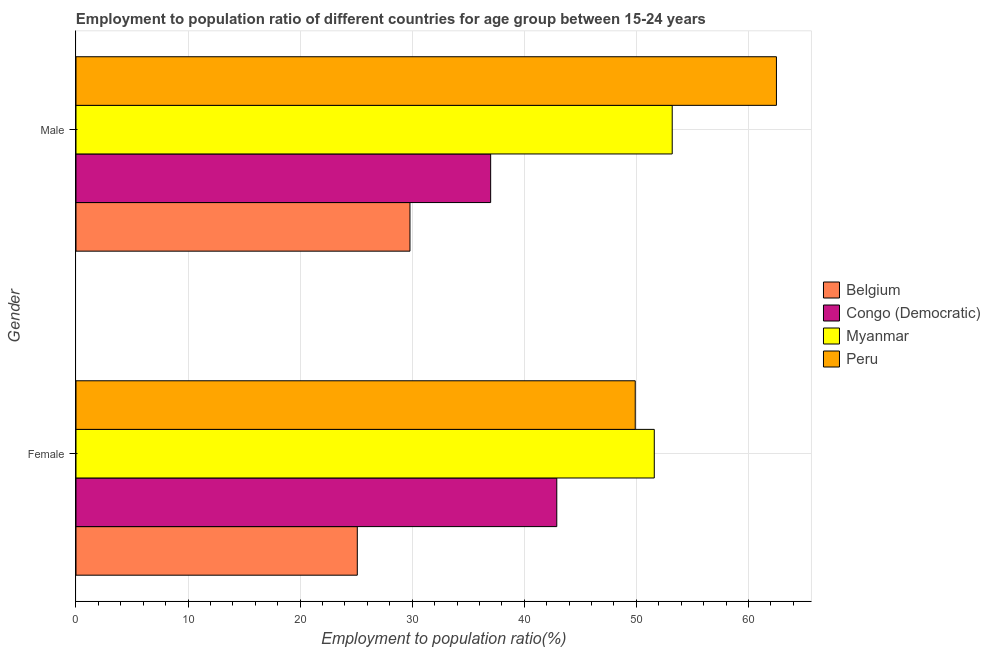How many groups of bars are there?
Provide a succinct answer. 2. How many bars are there on the 2nd tick from the top?
Offer a terse response. 4. What is the label of the 2nd group of bars from the top?
Keep it short and to the point. Female. What is the employment to population ratio(female) in Myanmar?
Keep it short and to the point. 51.6. Across all countries, what is the maximum employment to population ratio(male)?
Provide a short and direct response. 62.5. Across all countries, what is the minimum employment to population ratio(female)?
Provide a short and direct response. 25.1. In which country was the employment to population ratio(male) minimum?
Give a very brief answer. Belgium. What is the total employment to population ratio(female) in the graph?
Your answer should be compact. 169.5. What is the difference between the employment to population ratio(male) in Belgium and the employment to population ratio(female) in Peru?
Offer a very short reply. -20.1. What is the average employment to population ratio(female) per country?
Your answer should be compact. 42.38. What is the difference between the employment to population ratio(male) and employment to population ratio(female) in Myanmar?
Make the answer very short. 1.6. In how many countries, is the employment to population ratio(male) greater than 48 %?
Your response must be concise. 2. What is the ratio of the employment to population ratio(male) in Congo (Democratic) to that in Belgium?
Ensure brevity in your answer.  1.24. In how many countries, is the employment to population ratio(male) greater than the average employment to population ratio(male) taken over all countries?
Give a very brief answer. 2. What does the 2nd bar from the top in Male represents?
Make the answer very short. Myanmar. What does the 3rd bar from the bottom in Female represents?
Offer a terse response. Myanmar. Are the values on the major ticks of X-axis written in scientific E-notation?
Your response must be concise. No. Where does the legend appear in the graph?
Keep it short and to the point. Center right. What is the title of the graph?
Offer a terse response. Employment to population ratio of different countries for age group between 15-24 years. What is the label or title of the X-axis?
Your answer should be compact. Employment to population ratio(%). What is the label or title of the Y-axis?
Provide a succinct answer. Gender. What is the Employment to population ratio(%) in Belgium in Female?
Ensure brevity in your answer.  25.1. What is the Employment to population ratio(%) of Congo (Democratic) in Female?
Offer a terse response. 42.9. What is the Employment to population ratio(%) in Myanmar in Female?
Offer a very short reply. 51.6. What is the Employment to population ratio(%) in Peru in Female?
Give a very brief answer. 49.9. What is the Employment to population ratio(%) of Belgium in Male?
Make the answer very short. 29.8. What is the Employment to population ratio(%) of Congo (Democratic) in Male?
Your answer should be very brief. 37. What is the Employment to population ratio(%) of Myanmar in Male?
Your response must be concise. 53.2. What is the Employment to population ratio(%) of Peru in Male?
Make the answer very short. 62.5. Across all Gender, what is the maximum Employment to population ratio(%) in Belgium?
Ensure brevity in your answer.  29.8. Across all Gender, what is the maximum Employment to population ratio(%) of Congo (Democratic)?
Your response must be concise. 42.9. Across all Gender, what is the maximum Employment to population ratio(%) of Myanmar?
Provide a short and direct response. 53.2. Across all Gender, what is the maximum Employment to population ratio(%) in Peru?
Your answer should be compact. 62.5. Across all Gender, what is the minimum Employment to population ratio(%) of Belgium?
Make the answer very short. 25.1. Across all Gender, what is the minimum Employment to population ratio(%) of Congo (Democratic)?
Keep it short and to the point. 37. Across all Gender, what is the minimum Employment to population ratio(%) of Myanmar?
Ensure brevity in your answer.  51.6. Across all Gender, what is the minimum Employment to population ratio(%) in Peru?
Provide a succinct answer. 49.9. What is the total Employment to population ratio(%) in Belgium in the graph?
Your answer should be compact. 54.9. What is the total Employment to population ratio(%) of Congo (Democratic) in the graph?
Provide a succinct answer. 79.9. What is the total Employment to population ratio(%) in Myanmar in the graph?
Make the answer very short. 104.8. What is the total Employment to population ratio(%) of Peru in the graph?
Give a very brief answer. 112.4. What is the difference between the Employment to population ratio(%) of Belgium in Female and the Employment to population ratio(%) of Myanmar in Male?
Offer a very short reply. -28.1. What is the difference between the Employment to population ratio(%) in Belgium in Female and the Employment to population ratio(%) in Peru in Male?
Your answer should be very brief. -37.4. What is the difference between the Employment to population ratio(%) of Congo (Democratic) in Female and the Employment to population ratio(%) of Myanmar in Male?
Provide a short and direct response. -10.3. What is the difference between the Employment to population ratio(%) in Congo (Democratic) in Female and the Employment to population ratio(%) in Peru in Male?
Offer a terse response. -19.6. What is the difference between the Employment to population ratio(%) of Myanmar in Female and the Employment to population ratio(%) of Peru in Male?
Your answer should be compact. -10.9. What is the average Employment to population ratio(%) of Belgium per Gender?
Offer a terse response. 27.45. What is the average Employment to population ratio(%) in Congo (Democratic) per Gender?
Your answer should be very brief. 39.95. What is the average Employment to population ratio(%) of Myanmar per Gender?
Your answer should be very brief. 52.4. What is the average Employment to population ratio(%) in Peru per Gender?
Provide a succinct answer. 56.2. What is the difference between the Employment to population ratio(%) in Belgium and Employment to population ratio(%) in Congo (Democratic) in Female?
Your response must be concise. -17.8. What is the difference between the Employment to population ratio(%) in Belgium and Employment to population ratio(%) in Myanmar in Female?
Your answer should be compact. -26.5. What is the difference between the Employment to population ratio(%) of Belgium and Employment to population ratio(%) of Peru in Female?
Keep it short and to the point. -24.8. What is the difference between the Employment to population ratio(%) in Congo (Democratic) and Employment to population ratio(%) in Myanmar in Female?
Offer a terse response. -8.7. What is the difference between the Employment to population ratio(%) in Congo (Democratic) and Employment to population ratio(%) in Peru in Female?
Keep it short and to the point. -7. What is the difference between the Employment to population ratio(%) in Myanmar and Employment to population ratio(%) in Peru in Female?
Keep it short and to the point. 1.7. What is the difference between the Employment to population ratio(%) of Belgium and Employment to population ratio(%) of Congo (Democratic) in Male?
Provide a short and direct response. -7.2. What is the difference between the Employment to population ratio(%) of Belgium and Employment to population ratio(%) of Myanmar in Male?
Ensure brevity in your answer.  -23.4. What is the difference between the Employment to population ratio(%) of Belgium and Employment to population ratio(%) of Peru in Male?
Provide a succinct answer. -32.7. What is the difference between the Employment to population ratio(%) in Congo (Democratic) and Employment to population ratio(%) in Myanmar in Male?
Your answer should be compact. -16.2. What is the difference between the Employment to population ratio(%) in Congo (Democratic) and Employment to population ratio(%) in Peru in Male?
Provide a succinct answer. -25.5. What is the ratio of the Employment to population ratio(%) of Belgium in Female to that in Male?
Offer a terse response. 0.84. What is the ratio of the Employment to population ratio(%) in Congo (Democratic) in Female to that in Male?
Your answer should be very brief. 1.16. What is the ratio of the Employment to population ratio(%) in Myanmar in Female to that in Male?
Provide a succinct answer. 0.97. What is the ratio of the Employment to population ratio(%) in Peru in Female to that in Male?
Make the answer very short. 0.8. What is the difference between the highest and the second highest Employment to population ratio(%) of Peru?
Give a very brief answer. 12.6. What is the difference between the highest and the lowest Employment to population ratio(%) in Belgium?
Your response must be concise. 4.7. What is the difference between the highest and the lowest Employment to population ratio(%) in Myanmar?
Offer a very short reply. 1.6. What is the difference between the highest and the lowest Employment to population ratio(%) of Peru?
Provide a succinct answer. 12.6. 